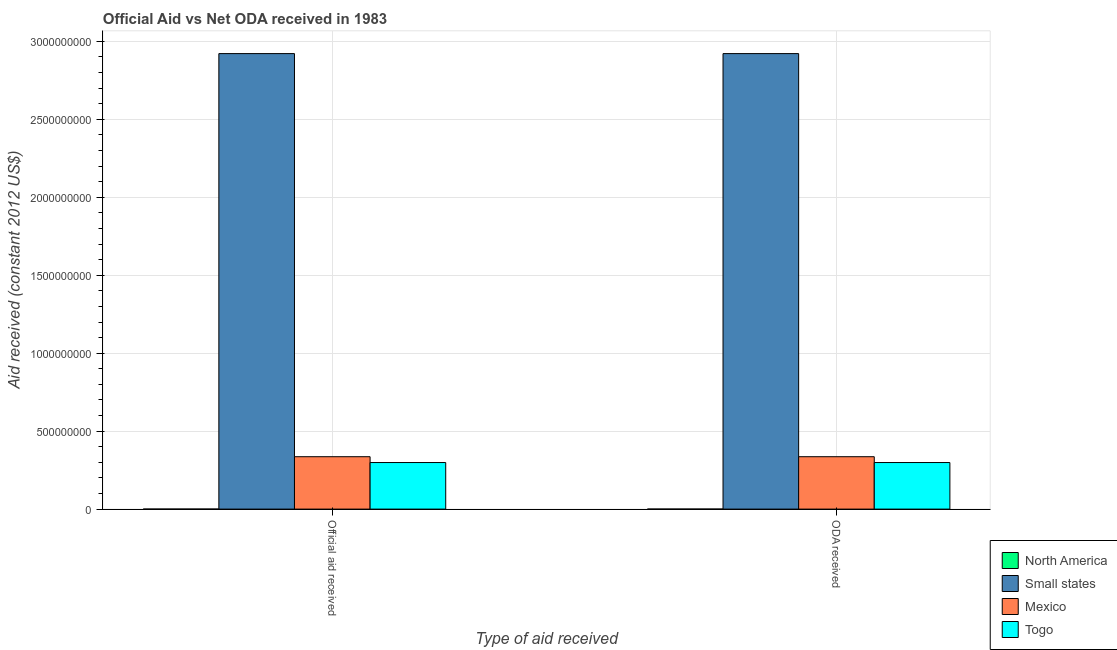How many bars are there on the 1st tick from the left?
Your answer should be very brief. 4. How many bars are there on the 1st tick from the right?
Offer a very short reply. 4. What is the label of the 1st group of bars from the left?
Give a very brief answer. Official aid received. What is the oda received in Small states?
Give a very brief answer. 2.92e+09. Across all countries, what is the maximum official aid received?
Offer a very short reply. 2.92e+09. Across all countries, what is the minimum official aid received?
Make the answer very short. 1.80e+05. In which country was the official aid received maximum?
Your response must be concise. Small states. In which country was the official aid received minimum?
Provide a short and direct response. North America. What is the total oda received in the graph?
Make the answer very short. 3.56e+09. What is the difference between the oda received in North America and that in Mexico?
Keep it short and to the point. -3.36e+08. What is the difference between the official aid received in Mexico and the oda received in Togo?
Ensure brevity in your answer.  3.74e+07. What is the average official aid received per country?
Make the answer very short. 8.89e+08. What is the difference between the official aid received and oda received in North America?
Your response must be concise. 0. In how many countries, is the oda received greater than 100000000 US$?
Provide a succinct answer. 3. What is the ratio of the oda received in Togo to that in Mexico?
Offer a terse response. 0.89. Does the graph contain any zero values?
Your response must be concise. No. How many legend labels are there?
Provide a short and direct response. 4. How are the legend labels stacked?
Your response must be concise. Vertical. What is the title of the graph?
Offer a very short reply. Official Aid vs Net ODA received in 1983 . Does "Liberia" appear as one of the legend labels in the graph?
Provide a short and direct response. No. What is the label or title of the X-axis?
Your answer should be compact. Type of aid received. What is the label or title of the Y-axis?
Keep it short and to the point. Aid received (constant 2012 US$). What is the Aid received (constant 2012 US$) in Small states in Official aid received?
Provide a succinct answer. 2.92e+09. What is the Aid received (constant 2012 US$) in Mexico in Official aid received?
Your answer should be compact. 3.36e+08. What is the Aid received (constant 2012 US$) of Togo in Official aid received?
Offer a very short reply. 2.99e+08. What is the Aid received (constant 2012 US$) in Small states in ODA received?
Your response must be concise. 2.92e+09. What is the Aid received (constant 2012 US$) of Mexico in ODA received?
Your response must be concise. 3.36e+08. What is the Aid received (constant 2012 US$) of Togo in ODA received?
Ensure brevity in your answer.  2.99e+08. Across all Type of aid received, what is the maximum Aid received (constant 2012 US$) in North America?
Give a very brief answer. 1.80e+05. Across all Type of aid received, what is the maximum Aid received (constant 2012 US$) in Small states?
Offer a very short reply. 2.92e+09. Across all Type of aid received, what is the maximum Aid received (constant 2012 US$) of Mexico?
Your response must be concise. 3.36e+08. Across all Type of aid received, what is the maximum Aid received (constant 2012 US$) of Togo?
Give a very brief answer. 2.99e+08. Across all Type of aid received, what is the minimum Aid received (constant 2012 US$) of North America?
Offer a terse response. 1.80e+05. Across all Type of aid received, what is the minimum Aid received (constant 2012 US$) in Small states?
Your answer should be very brief. 2.92e+09. Across all Type of aid received, what is the minimum Aid received (constant 2012 US$) in Mexico?
Your answer should be very brief. 3.36e+08. Across all Type of aid received, what is the minimum Aid received (constant 2012 US$) in Togo?
Make the answer very short. 2.99e+08. What is the total Aid received (constant 2012 US$) in Small states in the graph?
Ensure brevity in your answer.  5.84e+09. What is the total Aid received (constant 2012 US$) in Mexico in the graph?
Give a very brief answer. 6.72e+08. What is the total Aid received (constant 2012 US$) in Togo in the graph?
Provide a short and direct response. 5.97e+08. What is the difference between the Aid received (constant 2012 US$) in Small states in Official aid received and that in ODA received?
Offer a very short reply. 0. What is the difference between the Aid received (constant 2012 US$) in Togo in Official aid received and that in ODA received?
Your answer should be compact. 0. What is the difference between the Aid received (constant 2012 US$) in North America in Official aid received and the Aid received (constant 2012 US$) in Small states in ODA received?
Your answer should be very brief. -2.92e+09. What is the difference between the Aid received (constant 2012 US$) of North America in Official aid received and the Aid received (constant 2012 US$) of Mexico in ODA received?
Your answer should be compact. -3.36e+08. What is the difference between the Aid received (constant 2012 US$) of North America in Official aid received and the Aid received (constant 2012 US$) of Togo in ODA received?
Your response must be concise. -2.98e+08. What is the difference between the Aid received (constant 2012 US$) of Small states in Official aid received and the Aid received (constant 2012 US$) of Mexico in ODA received?
Make the answer very short. 2.59e+09. What is the difference between the Aid received (constant 2012 US$) in Small states in Official aid received and the Aid received (constant 2012 US$) in Togo in ODA received?
Offer a terse response. 2.62e+09. What is the difference between the Aid received (constant 2012 US$) in Mexico in Official aid received and the Aid received (constant 2012 US$) in Togo in ODA received?
Offer a very short reply. 3.74e+07. What is the average Aid received (constant 2012 US$) of North America per Type of aid received?
Give a very brief answer. 1.80e+05. What is the average Aid received (constant 2012 US$) of Small states per Type of aid received?
Provide a short and direct response. 2.92e+09. What is the average Aid received (constant 2012 US$) in Mexico per Type of aid received?
Offer a terse response. 3.36e+08. What is the average Aid received (constant 2012 US$) in Togo per Type of aid received?
Ensure brevity in your answer.  2.99e+08. What is the difference between the Aid received (constant 2012 US$) of North America and Aid received (constant 2012 US$) of Small states in Official aid received?
Keep it short and to the point. -2.92e+09. What is the difference between the Aid received (constant 2012 US$) of North America and Aid received (constant 2012 US$) of Mexico in Official aid received?
Your answer should be compact. -3.36e+08. What is the difference between the Aid received (constant 2012 US$) in North America and Aid received (constant 2012 US$) in Togo in Official aid received?
Ensure brevity in your answer.  -2.98e+08. What is the difference between the Aid received (constant 2012 US$) in Small states and Aid received (constant 2012 US$) in Mexico in Official aid received?
Keep it short and to the point. 2.59e+09. What is the difference between the Aid received (constant 2012 US$) of Small states and Aid received (constant 2012 US$) of Togo in Official aid received?
Provide a short and direct response. 2.62e+09. What is the difference between the Aid received (constant 2012 US$) in Mexico and Aid received (constant 2012 US$) in Togo in Official aid received?
Your response must be concise. 3.74e+07. What is the difference between the Aid received (constant 2012 US$) in North America and Aid received (constant 2012 US$) in Small states in ODA received?
Make the answer very short. -2.92e+09. What is the difference between the Aid received (constant 2012 US$) of North America and Aid received (constant 2012 US$) of Mexico in ODA received?
Provide a short and direct response. -3.36e+08. What is the difference between the Aid received (constant 2012 US$) of North America and Aid received (constant 2012 US$) of Togo in ODA received?
Provide a short and direct response. -2.98e+08. What is the difference between the Aid received (constant 2012 US$) in Small states and Aid received (constant 2012 US$) in Mexico in ODA received?
Provide a short and direct response. 2.59e+09. What is the difference between the Aid received (constant 2012 US$) in Small states and Aid received (constant 2012 US$) in Togo in ODA received?
Give a very brief answer. 2.62e+09. What is the difference between the Aid received (constant 2012 US$) in Mexico and Aid received (constant 2012 US$) in Togo in ODA received?
Make the answer very short. 3.74e+07. What is the ratio of the Aid received (constant 2012 US$) in North America in Official aid received to that in ODA received?
Offer a very short reply. 1. What is the ratio of the Aid received (constant 2012 US$) of Small states in Official aid received to that in ODA received?
Offer a terse response. 1. What is the ratio of the Aid received (constant 2012 US$) of Togo in Official aid received to that in ODA received?
Ensure brevity in your answer.  1. What is the difference between the highest and the second highest Aid received (constant 2012 US$) of North America?
Offer a very short reply. 0. What is the difference between the highest and the lowest Aid received (constant 2012 US$) in North America?
Your answer should be very brief. 0. What is the difference between the highest and the lowest Aid received (constant 2012 US$) in Small states?
Offer a very short reply. 0. What is the difference between the highest and the lowest Aid received (constant 2012 US$) in Mexico?
Your answer should be compact. 0. 